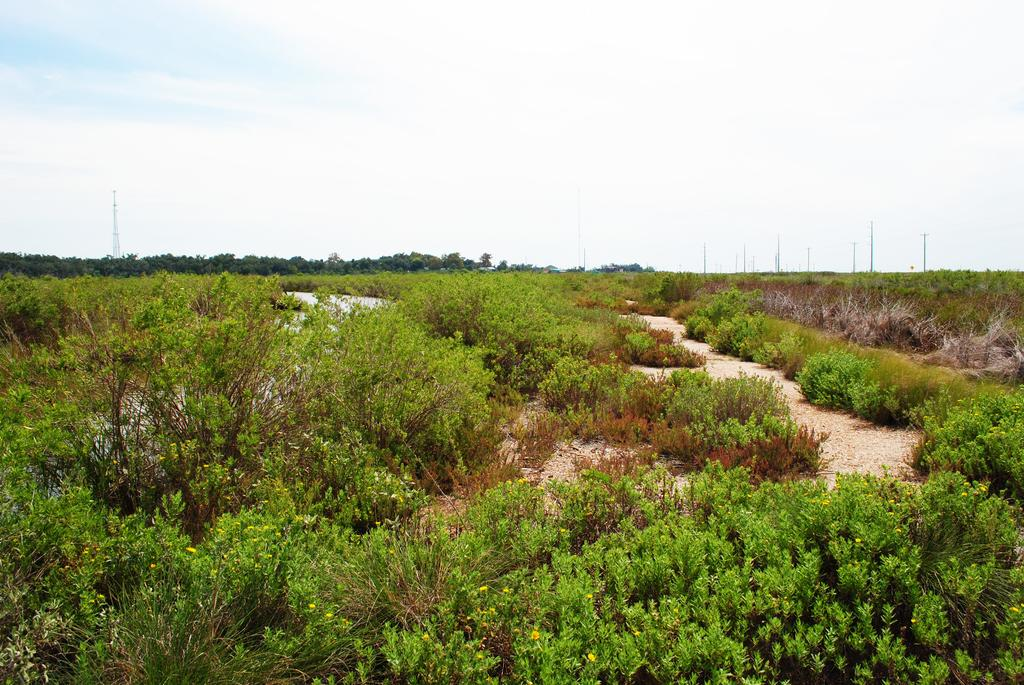What type of surface can be seen at the bottom of the image? The ground is visible in the image. What type of vegetation is present in the image? There are plants and trees in the image. What are the poles used for in the image? The purpose of the poles is not specified in the image. What is visible above the ground and vegetation in the image? The sky is visible in the image. Can you see any grapes growing on the trees in the image? There are no grapes visible in the image, as the trees are not identified as fruit-bearing trees. Is there any destruction or damage visible in the image? There is no indication of destruction or damage in the image; it appears to be a peaceful scene with plants, trees, and sky. 